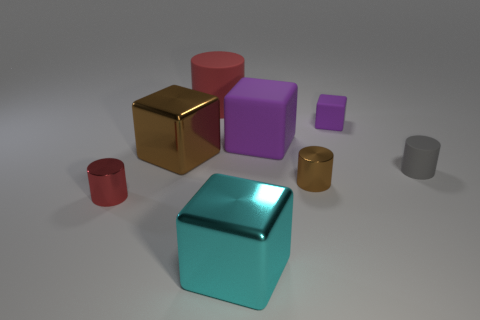What size is the brown object that is the same shape as the gray rubber thing?
Your response must be concise. Small. There is a cyan cube; how many small shiny things are behind it?
Provide a short and direct response. 2. There is a small metallic object behind the small cylinder left of the large brown thing; what color is it?
Offer a terse response. Brown. Is there any other thing that is the same shape as the gray rubber thing?
Provide a short and direct response. Yes. Are there the same number of red objects in front of the large purple matte object and small objects left of the large red matte object?
Keep it short and to the point. Yes. What number of cubes are large brown things or big matte things?
Ensure brevity in your answer.  2. How many other things are made of the same material as the large brown block?
Your response must be concise. 3. What is the shape of the brown object in front of the brown cube?
Offer a very short reply. Cylinder. What is the material of the large purple block behind the large metal thing that is behind the gray matte cylinder?
Ensure brevity in your answer.  Rubber. Are there more large cubes that are behind the small brown thing than metal balls?
Offer a terse response. Yes. 